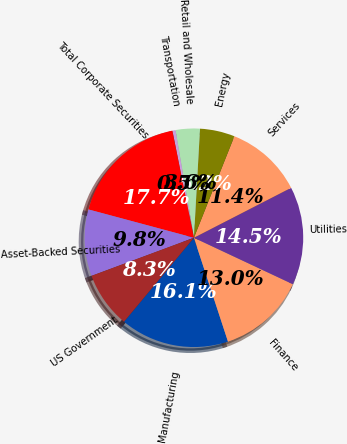Convert chart. <chart><loc_0><loc_0><loc_500><loc_500><pie_chart><fcel>Manufacturing<fcel>Finance<fcel>Utilities<fcel>Services<fcel>Energy<fcel>Retail and Wholesale<fcel>Transportation<fcel>Total Corporate Securities<fcel>Asset-Backed Securities<fcel>US Government<nl><fcel>16.1%<fcel>12.97%<fcel>14.54%<fcel>11.41%<fcel>5.15%<fcel>3.59%<fcel>0.46%<fcel>17.66%<fcel>9.84%<fcel>8.28%<nl></chart> 